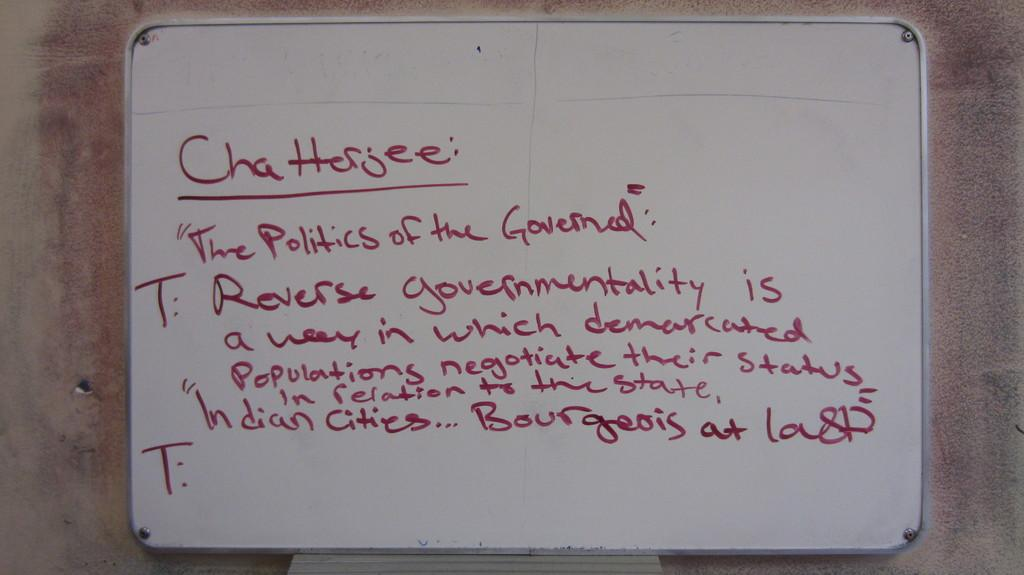<image>
Give a short and clear explanation of the subsequent image. A white marker board has red text on it that reads chattsjee on the top. 